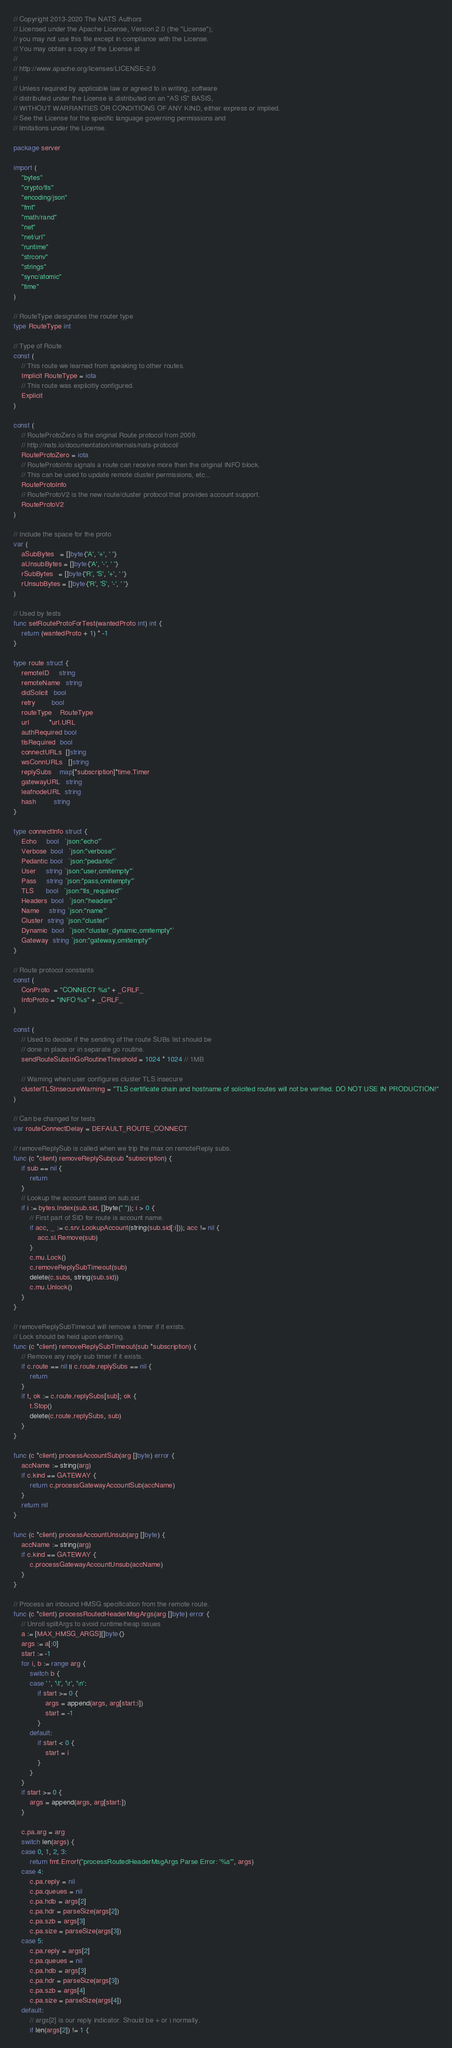Convert code to text. <code><loc_0><loc_0><loc_500><loc_500><_Go_>// Copyright 2013-2020 The NATS Authors
// Licensed under the Apache License, Version 2.0 (the "License");
// you may not use this file except in compliance with the License.
// You may obtain a copy of the License at
//
// http://www.apache.org/licenses/LICENSE-2.0
//
// Unless required by applicable law or agreed to in writing, software
// distributed under the License is distributed on an "AS IS" BASIS,
// WITHOUT WARRANTIES OR CONDITIONS OF ANY KIND, either express or implied.
// See the License for the specific language governing permissions and
// limitations under the License.

package server

import (
	"bytes"
	"crypto/tls"
	"encoding/json"
	"fmt"
	"math/rand"
	"net"
	"net/url"
	"runtime"
	"strconv"
	"strings"
	"sync/atomic"
	"time"
)

// RouteType designates the router type
type RouteType int

// Type of Route
const (
	// This route we learned from speaking to other routes.
	Implicit RouteType = iota
	// This route was explicitly configured.
	Explicit
)

const (
	// RouteProtoZero is the original Route protocol from 2009.
	// http://nats.io/documentation/internals/nats-protocol/
	RouteProtoZero = iota
	// RouteProtoInfo signals a route can receive more then the original INFO block.
	// This can be used to update remote cluster permissions, etc...
	RouteProtoInfo
	// RouteProtoV2 is the new route/cluster protocol that provides account support.
	RouteProtoV2
)

// Include the space for the proto
var (
	aSubBytes   = []byte{'A', '+', ' '}
	aUnsubBytes = []byte{'A', '-', ' '}
	rSubBytes   = []byte{'R', 'S', '+', ' '}
	rUnsubBytes = []byte{'R', 'S', '-', ' '}
)

// Used by tests
func setRouteProtoForTest(wantedProto int) int {
	return (wantedProto + 1) * -1
}

type route struct {
	remoteID     string
	remoteName   string
	didSolicit   bool
	retry        bool
	routeType    RouteType
	url          *url.URL
	authRequired bool
	tlsRequired  bool
	connectURLs  []string
	wsConnURLs   []string
	replySubs    map[*subscription]*time.Timer
	gatewayURL   string
	leafnodeURL  string
	hash         string
}

type connectInfo struct {
	Echo     bool   `json:"echo"`
	Verbose  bool   `json:"verbose"`
	Pedantic bool   `json:"pedantic"`
	User     string `json:"user,omitempty"`
	Pass     string `json:"pass,omitempty"`
	TLS      bool   `json:"tls_required"`
	Headers  bool   `json:"headers"`
	Name     string `json:"name"`
	Cluster  string `json:"cluster"`
	Dynamic  bool   `json:"cluster_dynamic,omitempty"`
	Gateway  string `json:"gateway,omitempty"`
}

// Route protocol constants
const (
	ConProto  = "CONNECT %s" + _CRLF_
	InfoProto = "INFO %s" + _CRLF_
)

const (
	// Used to decide if the sending of the route SUBs list should be
	// done in place or in separate go routine.
	sendRouteSubsInGoRoutineThreshold = 1024 * 1024 // 1MB

	// Warning when user configures cluster TLS insecure
	clusterTLSInsecureWarning = "TLS certificate chain and hostname of solicited routes will not be verified. DO NOT USE IN PRODUCTION!"
)

// Can be changed for tests
var routeConnectDelay = DEFAULT_ROUTE_CONNECT

// removeReplySub is called when we trip the max on remoteReply subs.
func (c *client) removeReplySub(sub *subscription) {
	if sub == nil {
		return
	}
	// Lookup the account based on sub.sid.
	if i := bytes.Index(sub.sid, []byte(" ")); i > 0 {
		// First part of SID for route is account name.
		if acc, _ := c.srv.LookupAccount(string(sub.sid[:i])); acc != nil {
			acc.sl.Remove(sub)
		}
		c.mu.Lock()
		c.removeReplySubTimeout(sub)
		delete(c.subs, string(sub.sid))
		c.mu.Unlock()
	}
}

// removeReplySubTimeout will remove a timer if it exists.
// Lock should be held upon entering.
func (c *client) removeReplySubTimeout(sub *subscription) {
	// Remove any reply sub timer if it exists.
	if c.route == nil || c.route.replySubs == nil {
		return
	}
	if t, ok := c.route.replySubs[sub]; ok {
		t.Stop()
		delete(c.route.replySubs, sub)
	}
}

func (c *client) processAccountSub(arg []byte) error {
	accName := string(arg)
	if c.kind == GATEWAY {
		return c.processGatewayAccountSub(accName)
	}
	return nil
}

func (c *client) processAccountUnsub(arg []byte) {
	accName := string(arg)
	if c.kind == GATEWAY {
		c.processGatewayAccountUnsub(accName)
	}
}

// Process an inbound HMSG specification from the remote route.
func (c *client) processRoutedHeaderMsgArgs(arg []byte) error {
	// Unroll splitArgs to avoid runtime/heap issues
	a := [MAX_HMSG_ARGS][]byte{}
	args := a[:0]
	start := -1
	for i, b := range arg {
		switch b {
		case ' ', '\t', '\r', '\n':
			if start >= 0 {
				args = append(args, arg[start:i])
				start = -1
			}
		default:
			if start < 0 {
				start = i
			}
		}
	}
	if start >= 0 {
		args = append(args, arg[start:])
	}

	c.pa.arg = arg
	switch len(args) {
	case 0, 1, 2, 3:
		return fmt.Errorf("processRoutedHeaderMsgArgs Parse Error: '%s'", args)
	case 4:
		c.pa.reply = nil
		c.pa.queues = nil
		c.pa.hdb = args[2]
		c.pa.hdr = parseSize(args[2])
		c.pa.szb = args[3]
		c.pa.size = parseSize(args[3])
	case 5:
		c.pa.reply = args[2]
		c.pa.queues = nil
		c.pa.hdb = args[3]
		c.pa.hdr = parseSize(args[3])
		c.pa.szb = args[4]
		c.pa.size = parseSize(args[4])
	default:
		// args[2] is our reply indicator. Should be + or | normally.
		if len(args[2]) != 1 {</code> 